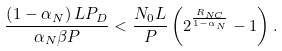<formula> <loc_0><loc_0><loc_500><loc_500>\frac { \left ( 1 - \alpha _ { N } \right ) L P _ { D } } { \alpha _ { N } \beta P } < \frac { N _ { 0 } L } { P } \left ( 2 ^ { \frac { R _ { N C } } { 1 - \alpha _ { N } } } - 1 \right ) .</formula> 